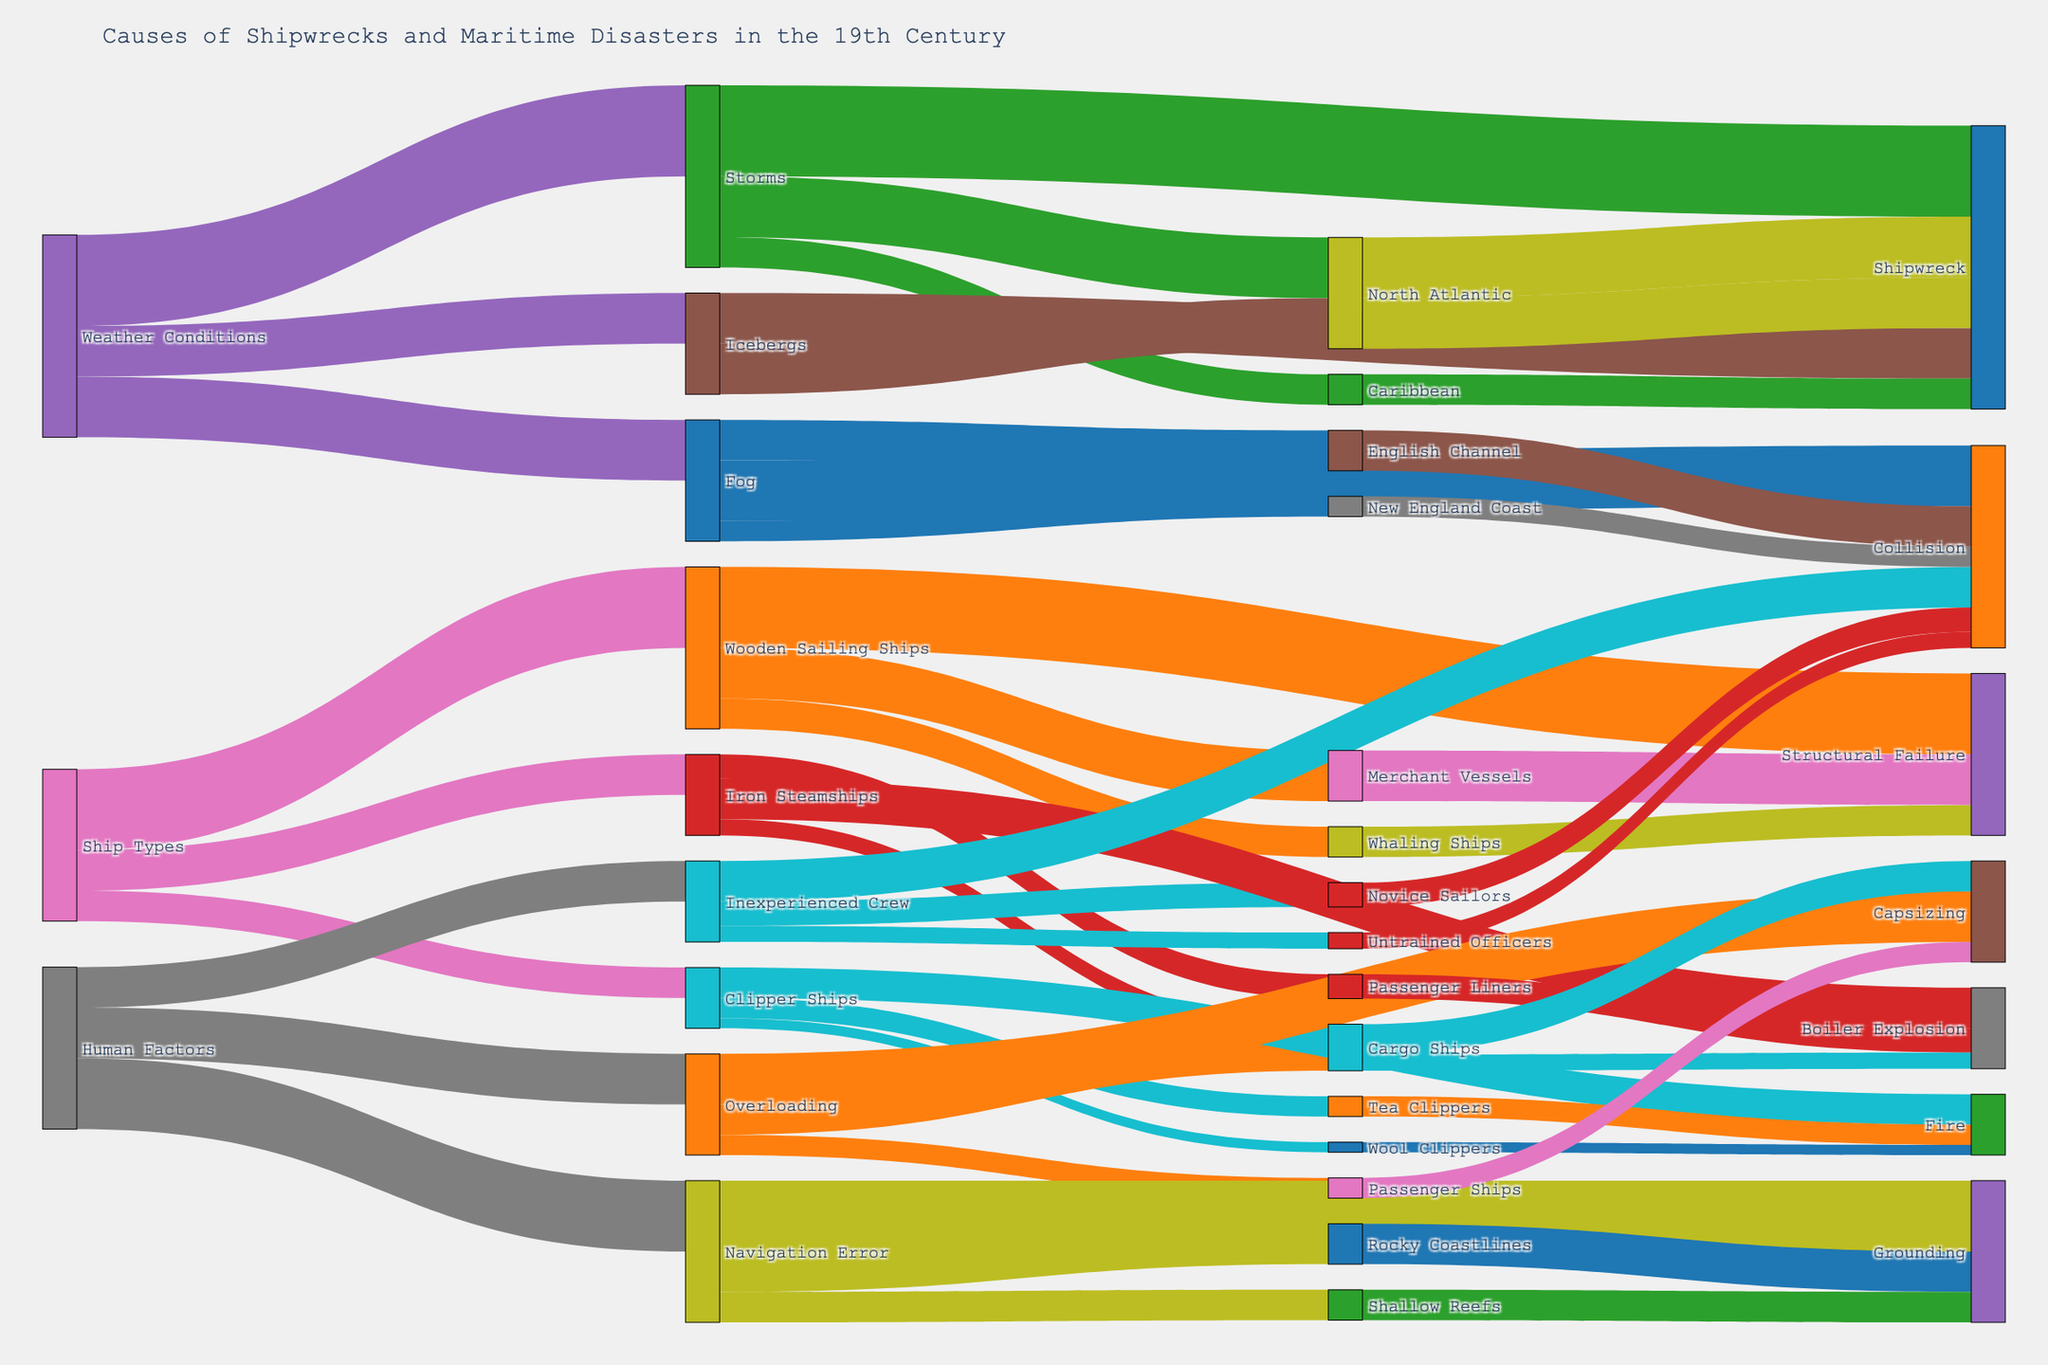What are the primary weather conditions leading to shipwrecks and maritime disasters in the 19th century? To identify the primary weather conditions, look at the initial connections in the Sankey diagram labeled "Weather Conditions". Observe the proportion of each condition leading to different types of disasters.
Answer: Storms, Fog, Icebergs Which weather condition caused the most shipwrecks? Follow the branches from "Weather Conditions" to "Shipwreck" and evaluate the values depicting the number of shipwrecks caused by each condition.
Answer: Storms What is the total number of shipwrecks caused by storms and icebergs? Add the values for shipwrecks caused by "Storms" and "Icebergs" from "Weather Conditions" to "Shipwreck". Storms contribute 45, and Icebergs contribute 25.
Answer: 70 What type of ships faced structural failure, and what were their respective values? Trace from "Ship Types" to "Structural Failure" and look at the intermediate connections showing different ship types and their values.
Answer: Wooden Sailing Ships (40) What is the most common human factor leading to grounding disasters? Follow the connections from "Human Factors" to "Grounding" and check which factor has the highest value. Navigation Error leads to grounding, verified by it having the highest value among factors leading to grounding.
Answer: Navigation Error Compare the number of shipwrecks in the North Atlantic and the Caribbean caused by storms. Which region had more shipwrecks? Follow branches from "Storms" to "North Atlantic" and "Caribbean" under "Shipwreck", then compare their values.
Answer: North Atlantic What is the most significant intermediate cause of collisions for human factors? Look at branches stemming from "Human Factors" to "Collision" and check the values corresponding to different intermediates. Inexperienced Crew has a value of 20 for collisions.
Answer: Inexperienced Crew Which weather condition leads to the most collisions, and how many collisions does it cause? Analyze connections from "Weather Conditions" leading to "Collision" and sum the values of those branches. Fog leading to "Collision" has the highest value of 30.
Answer: Fog, 30 Which ship types experienced the most boiler explosions, and what were the respective values? Look at the branches stemming from "Ship Types" to "Boiler Explosion" and check the intermediate values of various ship types. Iron Steamships are categorized under "Passenger Liners" and "Cargo Ships", contributing to the total for boiler explosions.
Answer: Iron Steamships (20) What is the combined total of grounding incidents caused by navigation errors on rocky coastlines and shallow reefs? Sum the values for "Navigation Error" leading to "Grounding" through "Rocky Coastlines" (20) and "Shallow Reefs" (15).
Answer: 35 